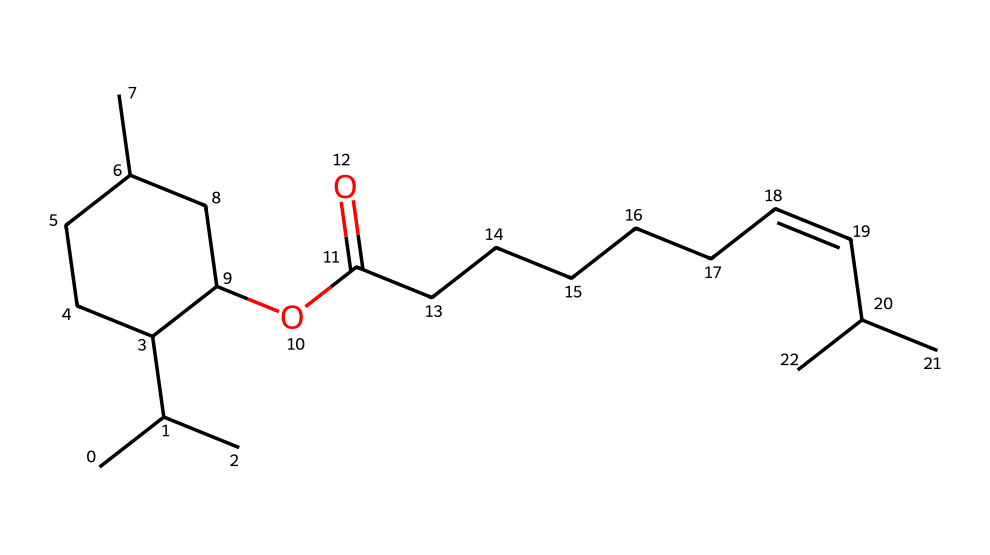What is the main functional group present in capsaicin? The structure shows a hydroxyl group (-OH) characteristic of phenols, confirming it as the main functional group in capsaicin.
Answer: hydroxyl How many carbon atoms are present in capsaicin? By analyzing the SMILES representation, there are a total of 18 carbon atoms counted throughout the structure.
Answer: 18 Does capsaicin contain any nitrogen atoms? Examining the molecular composition based on the SMILES shows that there are no nitrogen atoms present in capsaicin.
Answer: no What type of chemical is capsaicin classified as? The presence of the hydroxyl group and the carbon chain structure classifies capsaicin as a phenolic compound.
Answer: phenolic What is capsaicin's approximate molecular weight? Based on the sum of atomic masses for the shown structure, the calculated molecular weight of capsaicin is approximately 305 grams per mole.
Answer: 305 grams per mole What type of bond connects the carbon chains in capsaicin? The SMILES representation indicates single bonds predominantly along the carbon chain, with one double bond indicated within the structure.
Answer: single and double bonds What characteristic impact does the hydroxyl group have on capsaicin? The hydroxyl group contributes to capsaicin's solubility in water and plays a role in its spicy flavor perception through interaction with receptors.
Answer: solubility and flavor perception 